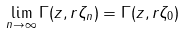<formula> <loc_0><loc_0><loc_500><loc_500>\lim _ { n \to \infty } \Gamma ( z , r \zeta _ { n } ) = \Gamma ( z , r \zeta _ { 0 } )</formula> 